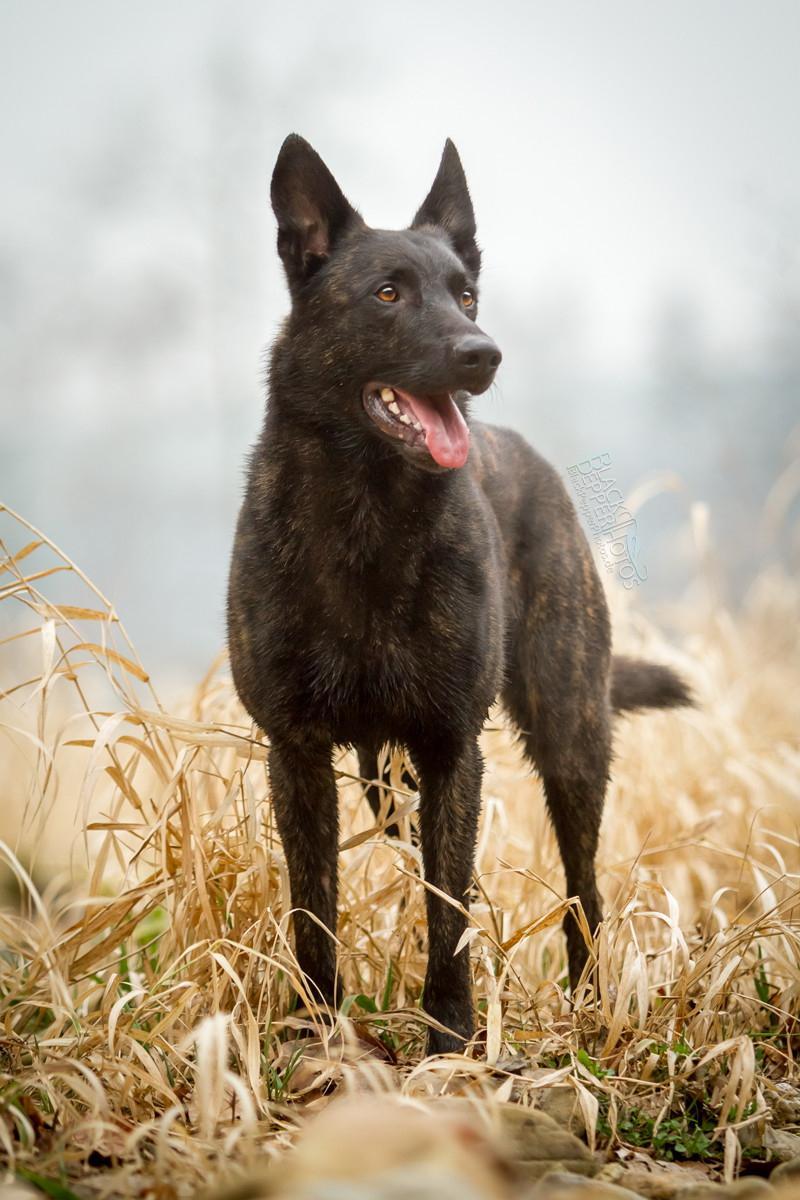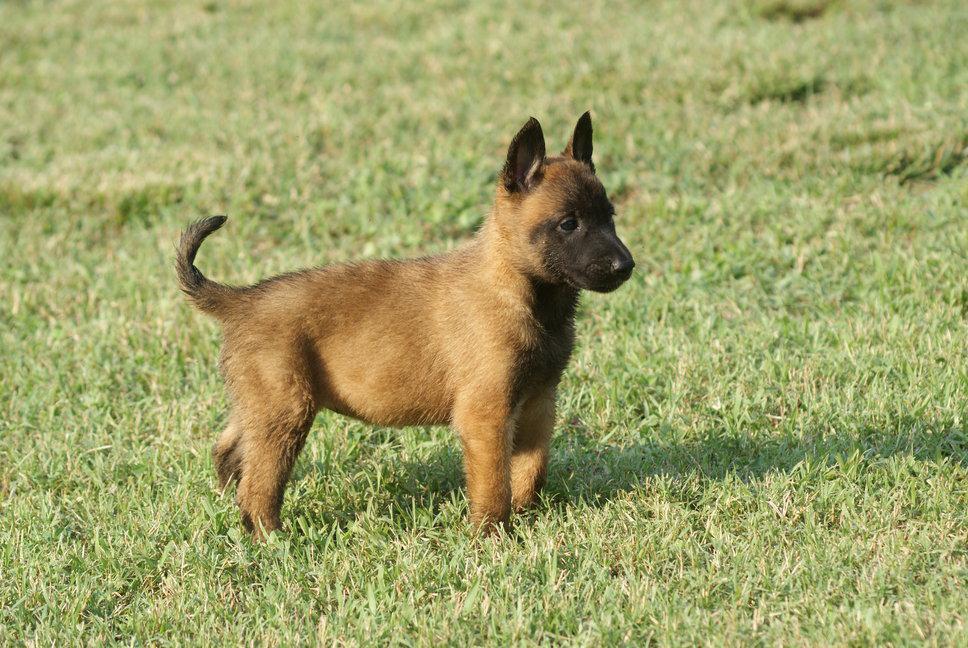The first image is the image on the left, the second image is the image on the right. Given the left and right images, does the statement "The dog in the left image is attached to a leash." hold true? Answer yes or no. No. The first image is the image on the left, the second image is the image on the right. For the images displayed, is the sentence "At least one dog is sitting in the grass." factually correct? Answer yes or no. No. 